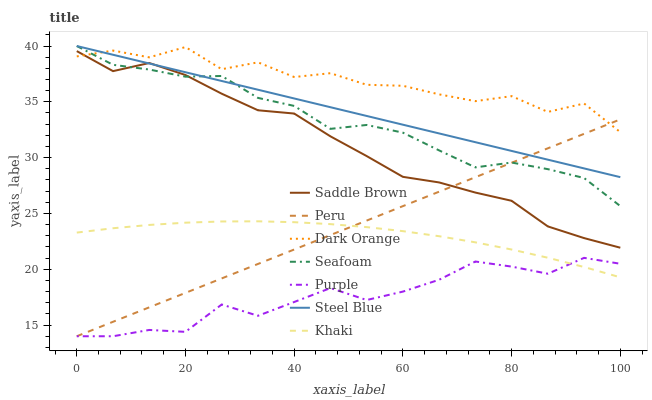Does Purple have the minimum area under the curve?
Answer yes or no. Yes. Does Dark Orange have the maximum area under the curve?
Answer yes or no. Yes. Does Khaki have the minimum area under the curve?
Answer yes or no. No. Does Khaki have the maximum area under the curve?
Answer yes or no. No. Is Steel Blue the smoothest?
Answer yes or no. Yes. Is Dark Orange the roughest?
Answer yes or no. Yes. Is Khaki the smoothest?
Answer yes or no. No. Is Khaki the roughest?
Answer yes or no. No. Does Purple have the lowest value?
Answer yes or no. Yes. Does Khaki have the lowest value?
Answer yes or no. No. Does Seafoam have the highest value?
Answer yes or no. Yes. Does Khaki have the highest value?
Answer yes or no. No. Is Khaki less than Steel Blue?
Answer yes or no. Yes. Is Seafoam greater than Purple?
Answer yes or no. Yes. Does Purple intersect Peru?
Answer yes or no. Yes. Is Purple less than Peru?
Answer yes or no. No. Is Purple greater than Peru?
Answer yes or no. No. Does Khaki intersect Steel Blue?
Answer yes or no. No. 